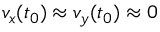Convert formula to latex. <formula><loc_0><loc_0><loc_500><loc_500>v _ { x } ( t _ { 0 } ) \approx v _ { y } ( t _ { 0 } ) \approx 0</formula> 